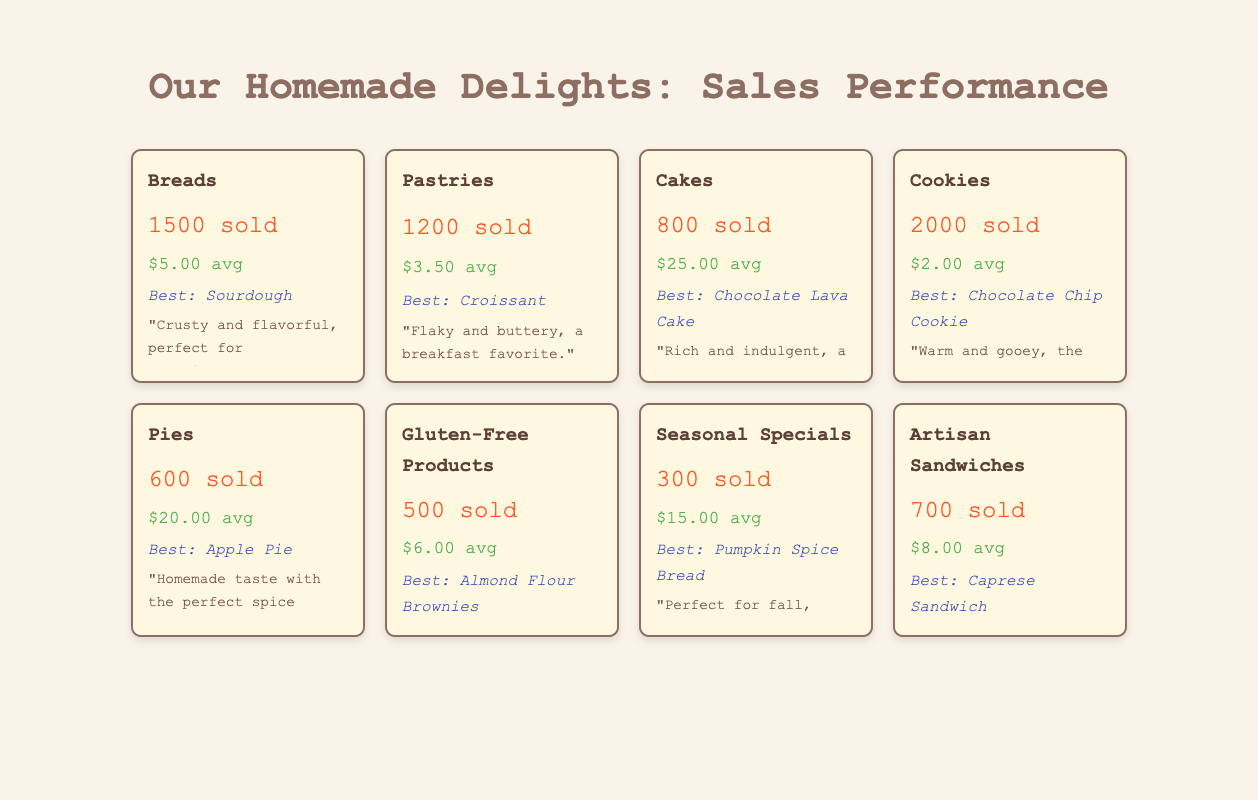What is the best-selling product in the "Cookies" category? The table indicates that the best-selling product in the "Cookies" category is the "Chocolate Chip Cookie."
Answer: Chocolate Chip Cookie Which product category has the highest sales volume? The "Cookies" category has the highest sales volume with 2000 sold, surpassing all other categories listed in the table.
Answer: Cookies What is the average price of products in the "Breads" category? The average price for the "Breads" category is stated directly in the table as $5.00.
Answer: $5.00 How many more units were sold in the "Cookies" category than the "Pies" category? The "Cookies" category sold 2000 units, while the "Pies" category sold 600 units. The difference is 2000 - 600 = 1400.
Answer: 1400 Is "Gluten-Free Products" the best-selling category? No, the "Gluten-Free Products" category has a sales volume of 500, which is lower than multiple other categories, including "Cookies" (2000) and "Breads" (1500).
Answer: No What is the total sales volume for the "Cakes" and "Pies" categories combined? The sales volume for "Cakes" is 800 and for "Pies" is 600. Adding these two values gives 800 + 600 = 1400.
Answer: 1400 Which category has the lowest sales volume? Looking at the sales volumes noted in the table, "Seasonal Specials" has the lowest sales volume with 300 sold.
Answer: Seasonal Specials What is the average price of all product categories? The average price can be calculated by adding the average prices from each category: (5 + 3.5 + 25 + 2 + 20 + 6 + 15 + 8) = 84.5 and then dividing by the total number of categories (8), which gives 84.5 / 8 = 10.56.
Answer: $10.56 